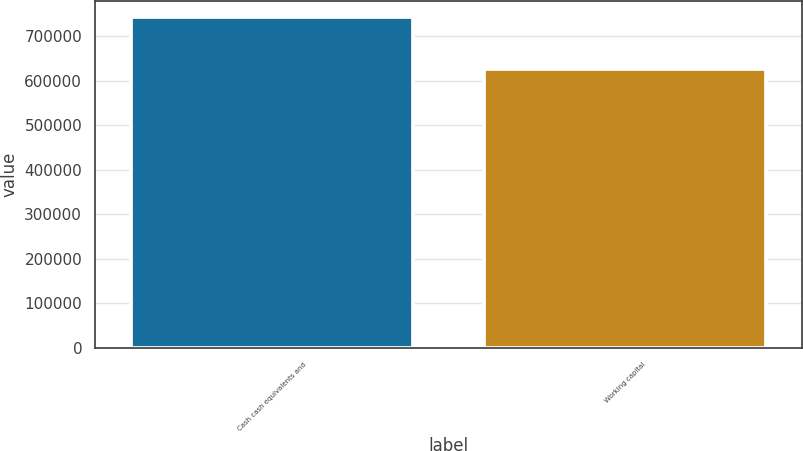Convert chart to OTSL. <chart><loc_0><loc_0><loc_500><loc_500><bar_chart><fcel>Cash cash equivalents and<fcel>Working capital<nl><fcel>742986<fcel>627165<nl></chart> 